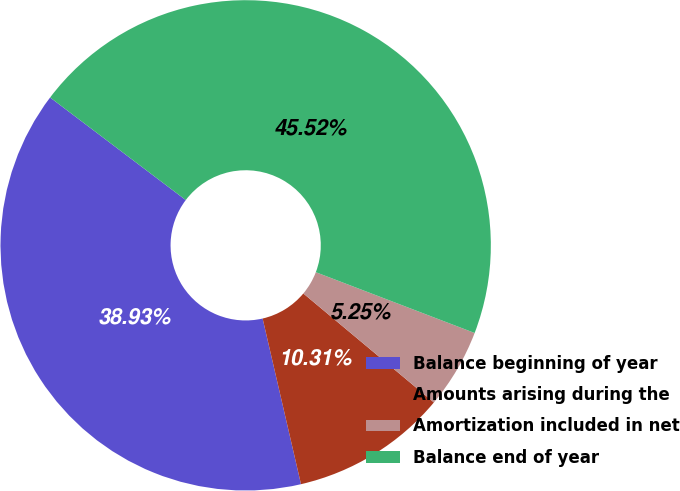Convert chart. <chart><loc_0><loc_0><loc_500><loc_500><pie_chart><fcel>Balance beginning of year<fcel>Amounts arising during the<fcel>Amortization included in net<fcel>Balance end of year<nl><fcel>38.93%<fcel>10.31%<fcel>5.25%<fcel>45.52%<nl></chart> 